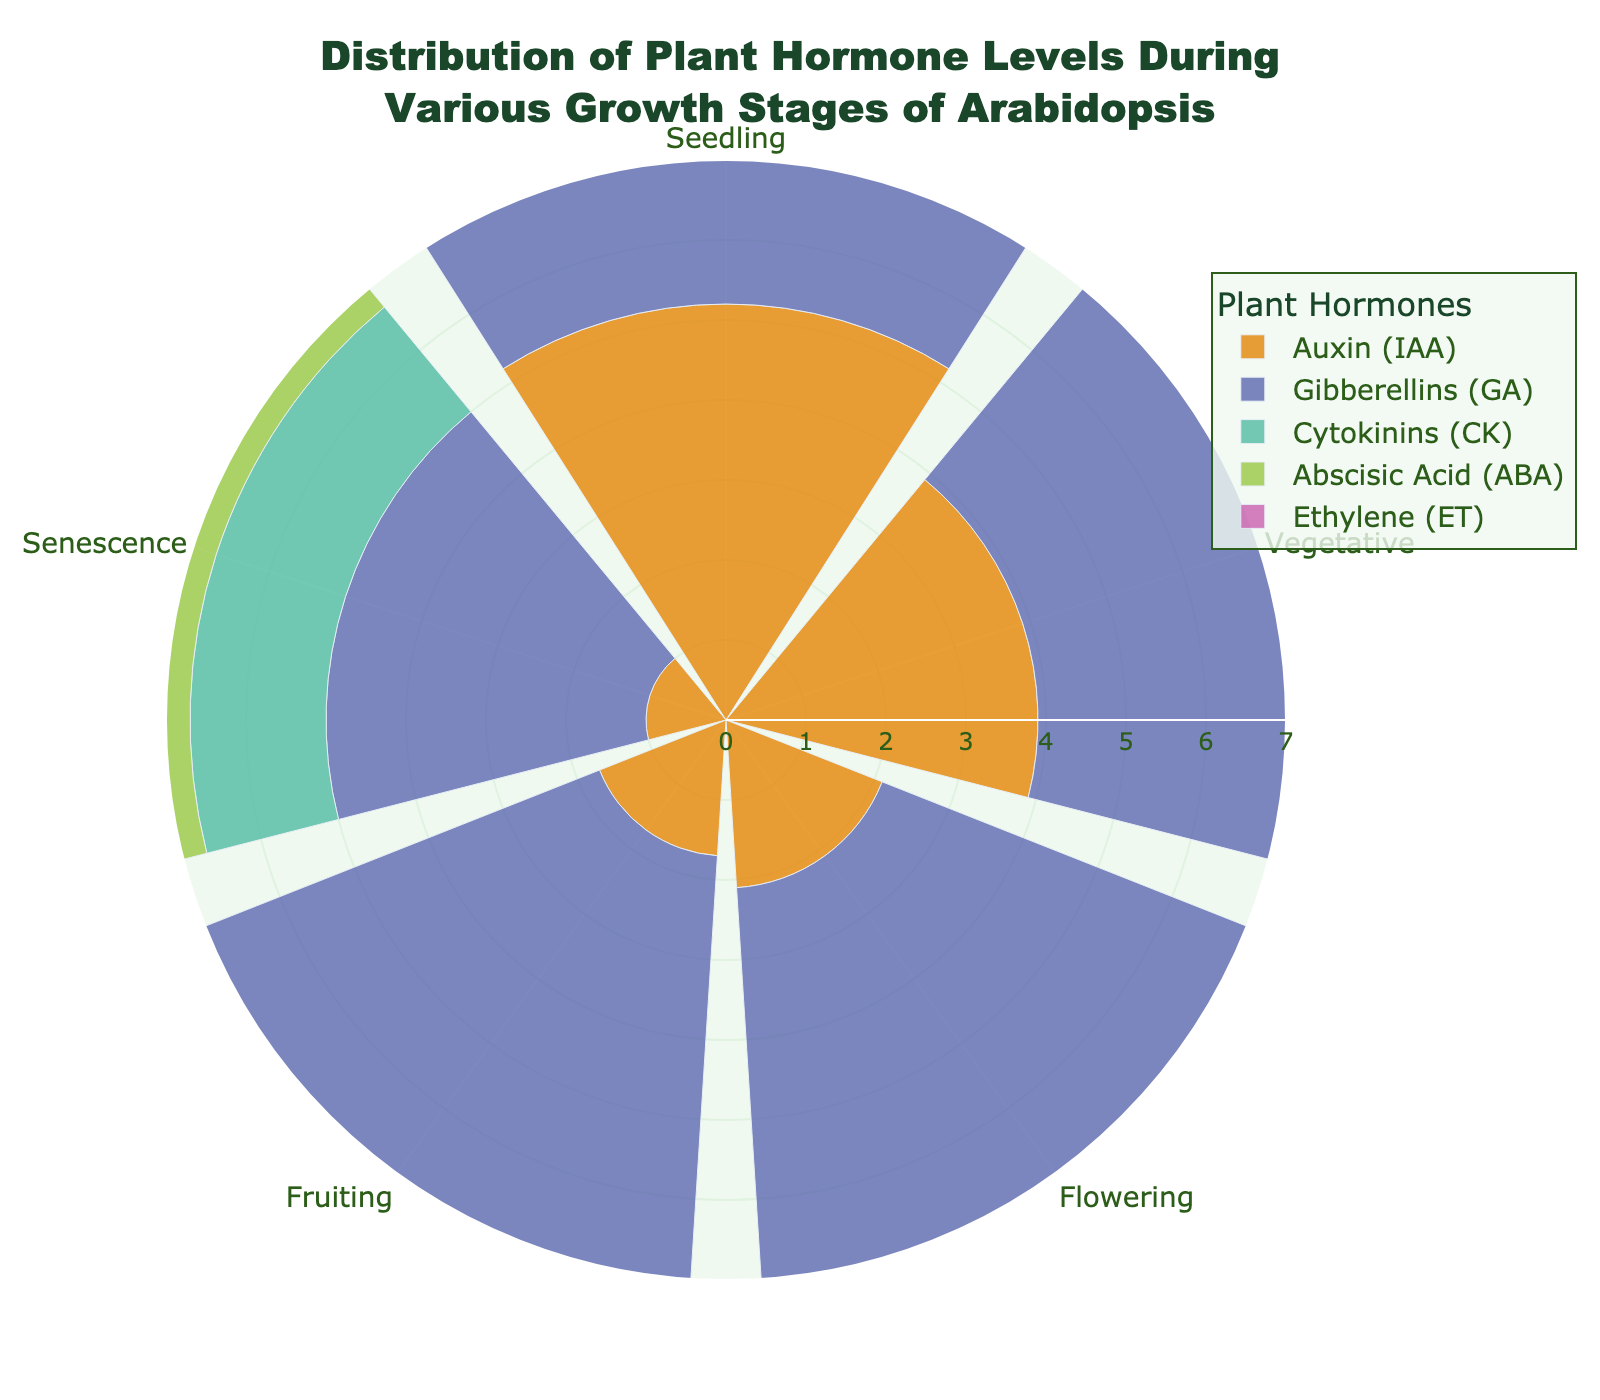What is the title of the chart? The title is located at the top center of the chart, which is typically distinguished by its font size and style. The title reads "Distribution of Plant Hormone Levels During Various Growth Stages of Arabidopsis."
Answer: Distribution of Plant Hormone Levels During Various Growth Stages of Arabidopsis Which plant hormone has the highest level in the Flowering stage? Locate the segment corresponding to the Flowering stage and compare the levels of all hormones. Gibberellins (GA) has the highest level in the Flowering stage with a value of 5.7.
Answer: Gibberellins (GA) What is the sum of Auxin (IAA) levels across all growth stages? Sum the values of Auxin (IAA) from all the given growth stages: Seedling (5.2) + Vegetative (3.9) + Flowering (2.1) + Fruiting (1.7) + Senescence (1.0) = 13.9.
Answer: 13.9 Which growth stage has the lowest level of Cytokinins (CK)? Check the levels of Cytokinins (CK) across all growth stages and identify the lowest value. The Seedling stage has the lowest Cytokinins (CK) level at 1.1.
Answer: Seedling Compare the levels of Abscisic Acid (ABA) during Fruiting and Senescence. Which stage has a higher level? Compare the levels of Abscisic Acid (ABA) for Fruiting (3.5) and Senescence (5.0). Senescence has a higher level.
Answer: Senescence In which growth stage is Ethylene (ET) level the highest? Look at the values of Ethylene (ET) across all growth stages and find the maximum value. The highest level is in the Senescence stage with a value of 4.3.
Answer: Senescence What is the average level of Gibberellins (GA) across all growth stages? Add the levels of Gibberellins (GA) for all growth stages: 2.3 (Seedling) + 4.5 (Vegetative) + 5.7 (Flowering) + 6.2 (Fruiting) + 4.0 (Senescence) = 22.7. Divide by the number of stages, which is 5. The average is 22.7 / 5 = 4.54.
Answer: 4.54 What is the difference in Abscisic Acid (ABA) levels between the Fruiting and Seedling stages? Subtract the ABA level in the Seedling stage from the Fruiting stage: 3.5 (Fruiting) - 0.5 (Seedling) = 3.0.
Answer: 3.0 Which hormone experiences the most significant increase from Seedling to Senescence? Calculate the difference for each hormone from Seedling to Senescence, and find the largest increase: Auxin (1.0 - 5.2 = -4.2), Gibberellins (4.0 - 2.3 = 1.7), Cytokinins (1.7 - 1.1 = 0.6), Abscisic Acid (5.0 - 0.5 = 4.5), Ethylene (4.3 - 0.8 = 3.5). Abscisic Acid has the most significant increase of 4.5.
Answer: Abscisic Acid (ABA) 